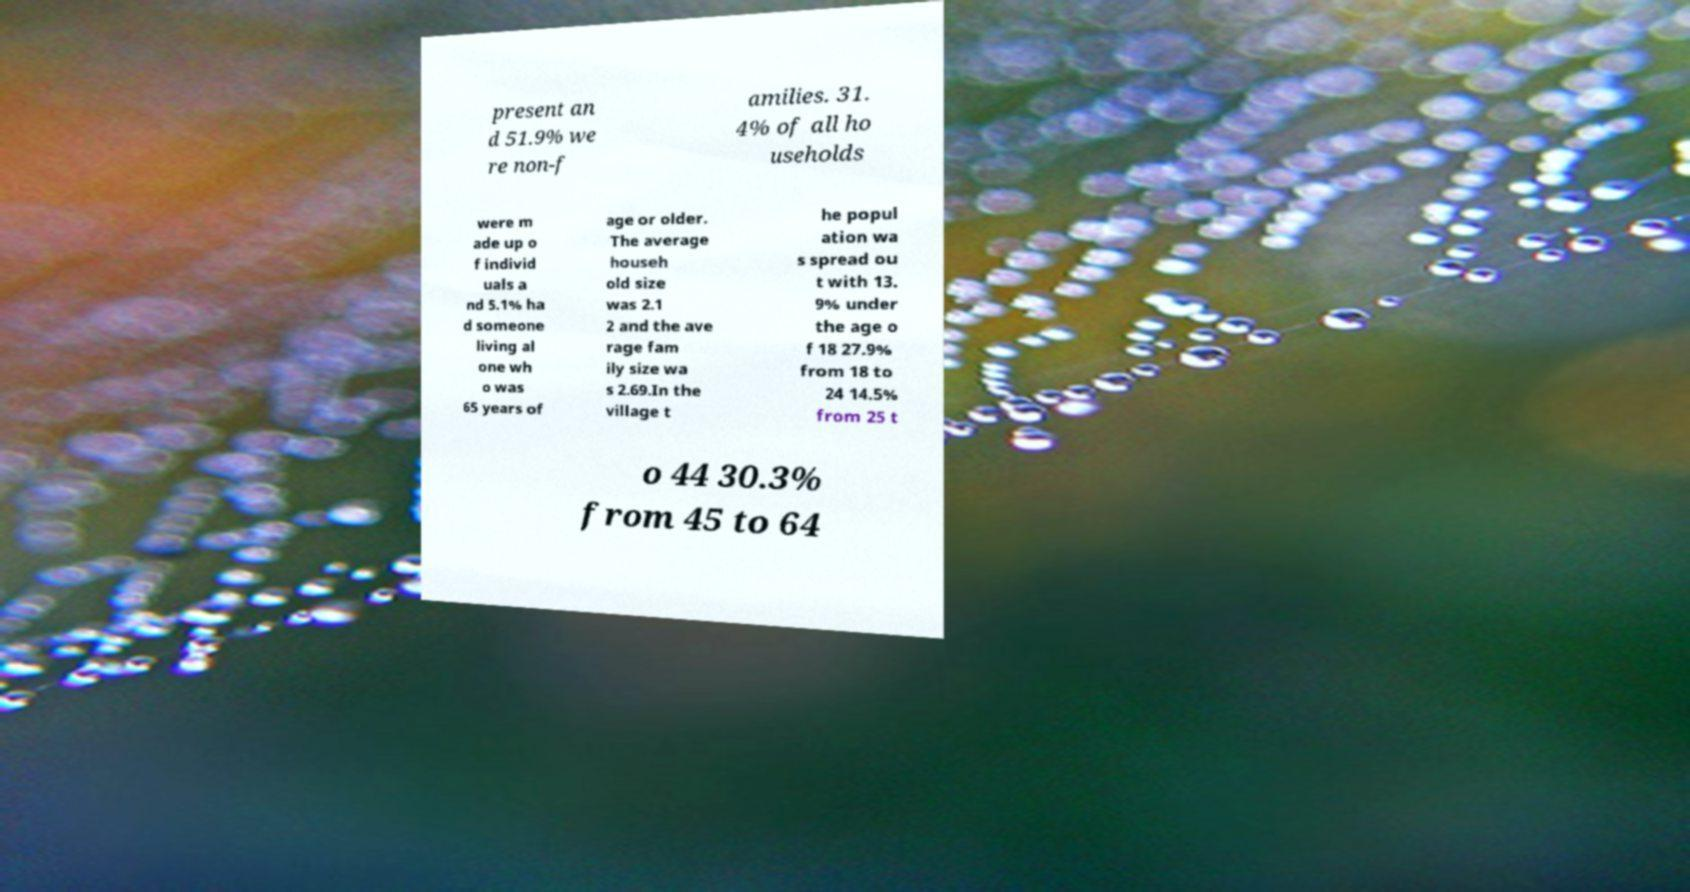Could you extract and type out the text from this image? present an d 51.9% we re non-f amilies. 31. 4% of all ho useholds were m ade up o f individ uals a nd 5.1% ha d someone living al one wh o was 65 years of age or older. The average househ old size was 2.1 2 and the ave rage fam ily size wa s 2.69.In the village t he popul ation wa s spread ou t with 13. 9% under the age o f 18 27.9% from 18 to 24 14.5% from 25 t o 44 30.3% from 45 to 64 